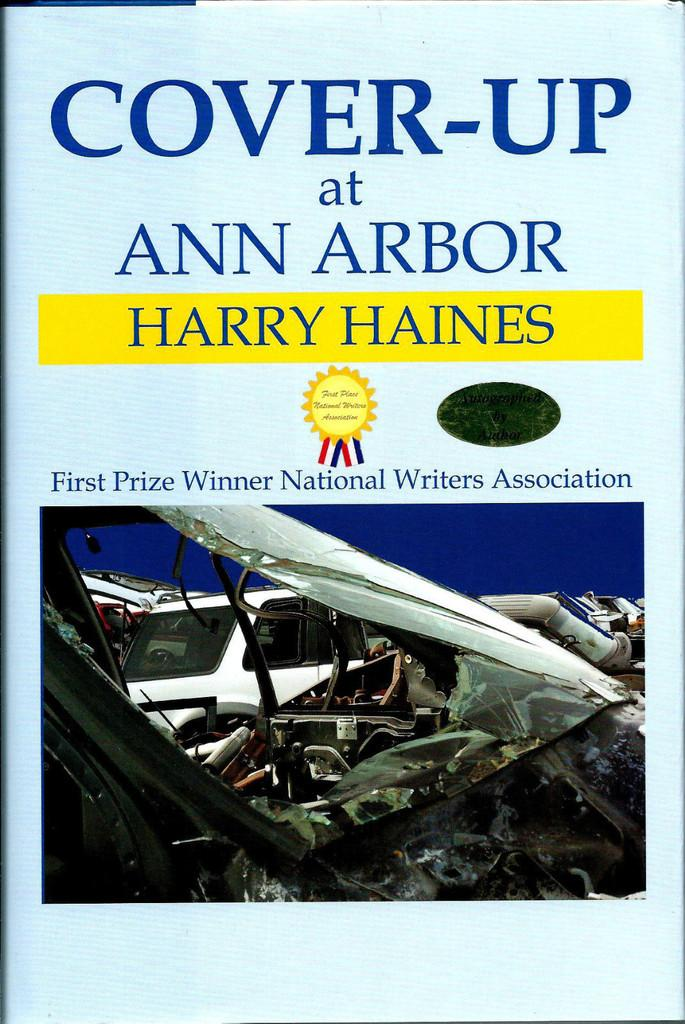<image>
Write a terse but informative summary of the picture. Harry Haines wrote a book entitled Cover Up at Ann Arbor. 